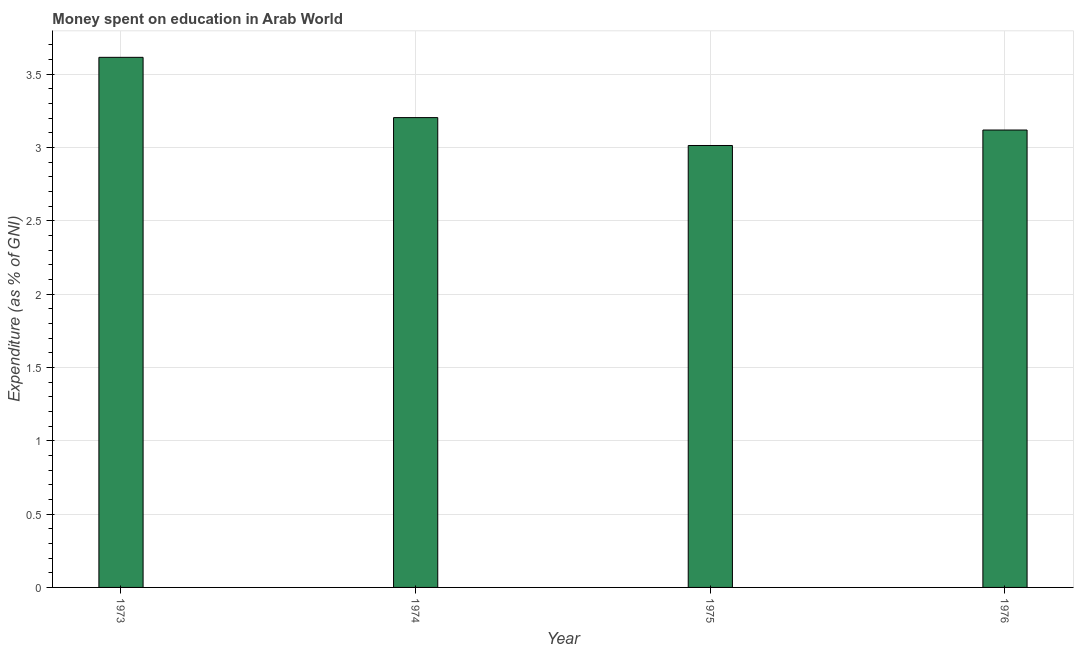What is the title of the graph?
Your answer should be compact. Money spent on education in Arab World. What is the label or title of the X-axis?
Your answer should be very brief. Year. What is the label or title of the Y-axis?
Make the answer very short. Expenditure (as % of GNI). What is the expenditure on education in 1973?
Offer a terse response. 3.61. Across all years, what is the maximum expenditure on education?
Provide a short and direct response. 3.61. Across all years, what is the minimum expenditure on education?
Give a very brief answer. 3.01. In which year was the expenditure on education minimum?
Offer a terse response. 1975. What is the sum of the expenditure on education?
Make the answer very short. 12.95. What is the difference between the expenditure on education in 1973 and 1974?
Ensure brevity in your answer.  0.41. What is the average expenditure on education per year?
Your answer should be compact. 3.24. What is the median expenditure on education?
Your answer should be very brief. 3.16. Is the expenditure on education in 1973 less than that in 1975?
Offer a terse response. No. Is the difference between the expenditure on education in 1973 and 1975 greater than the difference between any two years?
Your answer should be compact. Yes. What is the difference between the highest and the second highest expenditure on education?
Offer a terse response. 0.41. Is the sum of the expenditure on education in 1975 and 1976 greater than the maximum expenditure on education across all years?
Give a very brief answer. Yes. What is the difference between the highest and the lowest expenditure on education?
Your answer should be compact. 0.6. How many bars are there?
Offer a terse response. 4. What is the difference between two consecutive major ticks on the Y-axis?
Ensure brevity in your answer.  0.5. Are the values on the major ticks of Y-axis written in scientific E-notation?
Your answer should be compact. No. What is the Expenditure (as % of GNI) of 1973?
Your answer should be very brief. 3.61. What is the Expenditure (as % of GNI) of 1974?
Your answer should be compact. 3.2. What is the Expenditure (as % of GNI) in 1975?
Provide a short and direct response. 3.01. What is the Expenditure (as % of GNI) in 1976?
Your answer should be very brief. 3.12. What is the difference between the Expenditure (as % of GNI) in 1973 and 1974?
Give a very brief answer. 0.41. What is the difference between the Expenditure (as % of GNI) in 1973 and 1975?
Your answer should be compact. 0.6. What is the difference between the Expenditure (as % of GNI) in 1973 and 1976?
Ensure brevity in your answer.  0.5. What is the difference between the Expenditure (as % of GNI) in 1974 and 1975?
Your response must be concise. 0.19. What is the difference between the Expenditure (as % of GNI) in 1974 and 1976?
Provide a short and direct response. 0.08. What is the difference between the Expenditure (as % of GNI) in 1975 and 1976?
Make the answer very short. -0.11. What is the ratio of the Expenditure (as % of GNI) in 1973 to that in 1974?
Offer a terse response. 1.13. What is the ratio of the Expenditure (as % of GNI) in 1973 to that in 1976?
Your answer should be compact. 1.16. What is the ratio of the Expenditure (as % of GNI) in 1974 to that in 1975?
Make the answer very short. 1.06. What is the ratio of the Expenditure (as % of GNI) in 1975 to that in 1976?
Your answer should be compact. 0.97. 